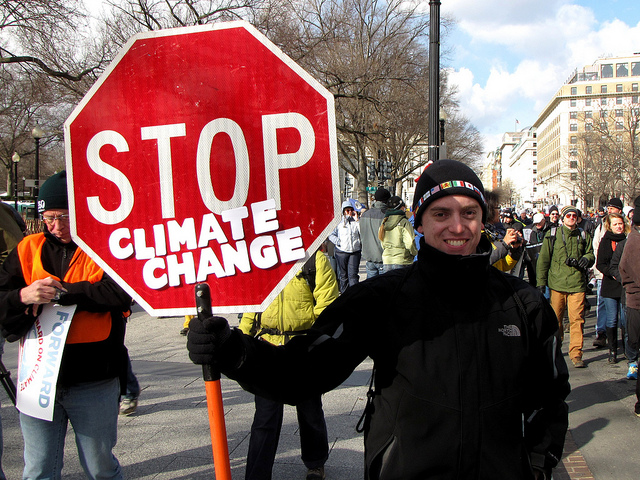Identify and read out the text in this image. STOP CLIMATE CLIMATE CHANGE FORWARD 